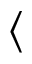Convert formula to latex. <formula><loc_0><loc_0><loc_500><loc_500>\langle</formula> 